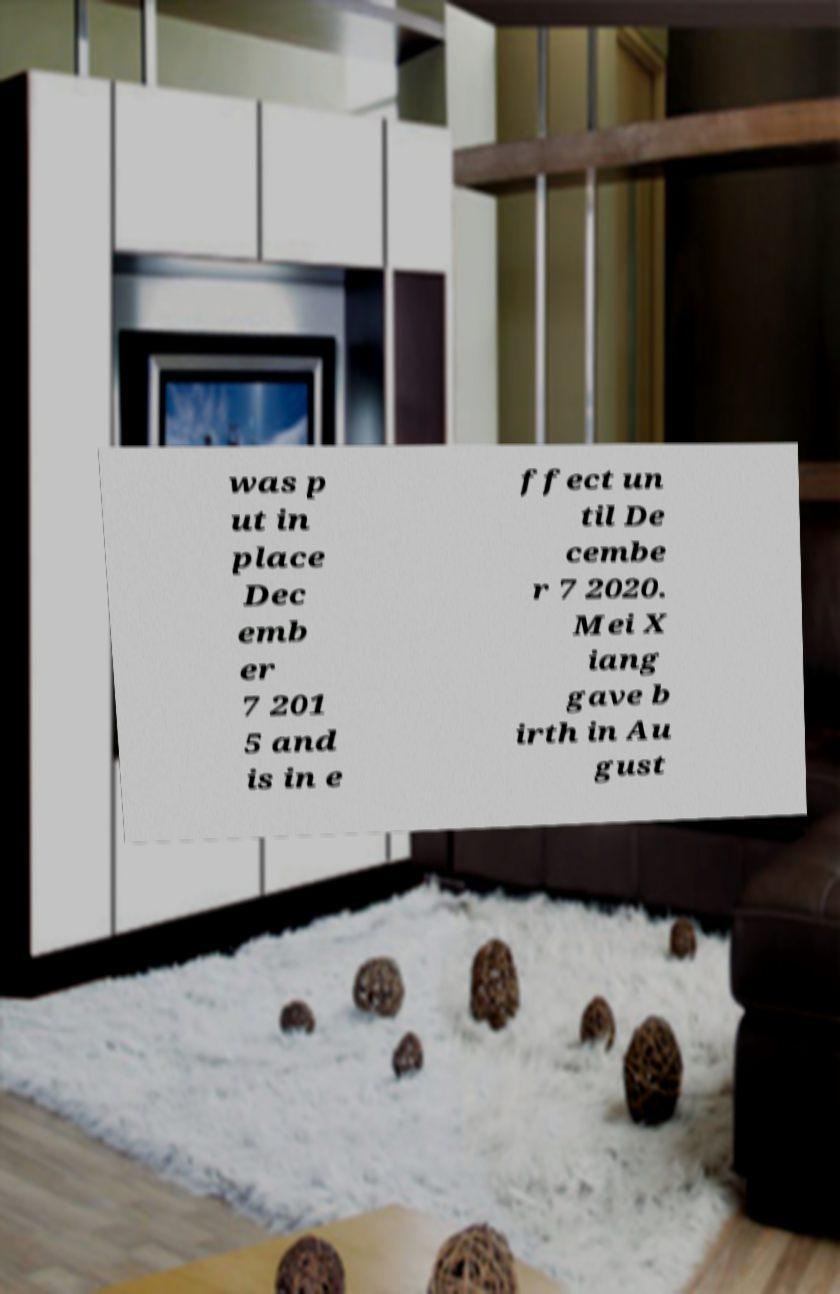Can you read and provide the text displayed in the image?This photo seems to have some interesting text. Can you extract and type it out for me? was p ut in place Dec emb er 7 201 5 and is in e ffect un til De cembe r 7 2020. Mei X iang gave b irth in Au gust 